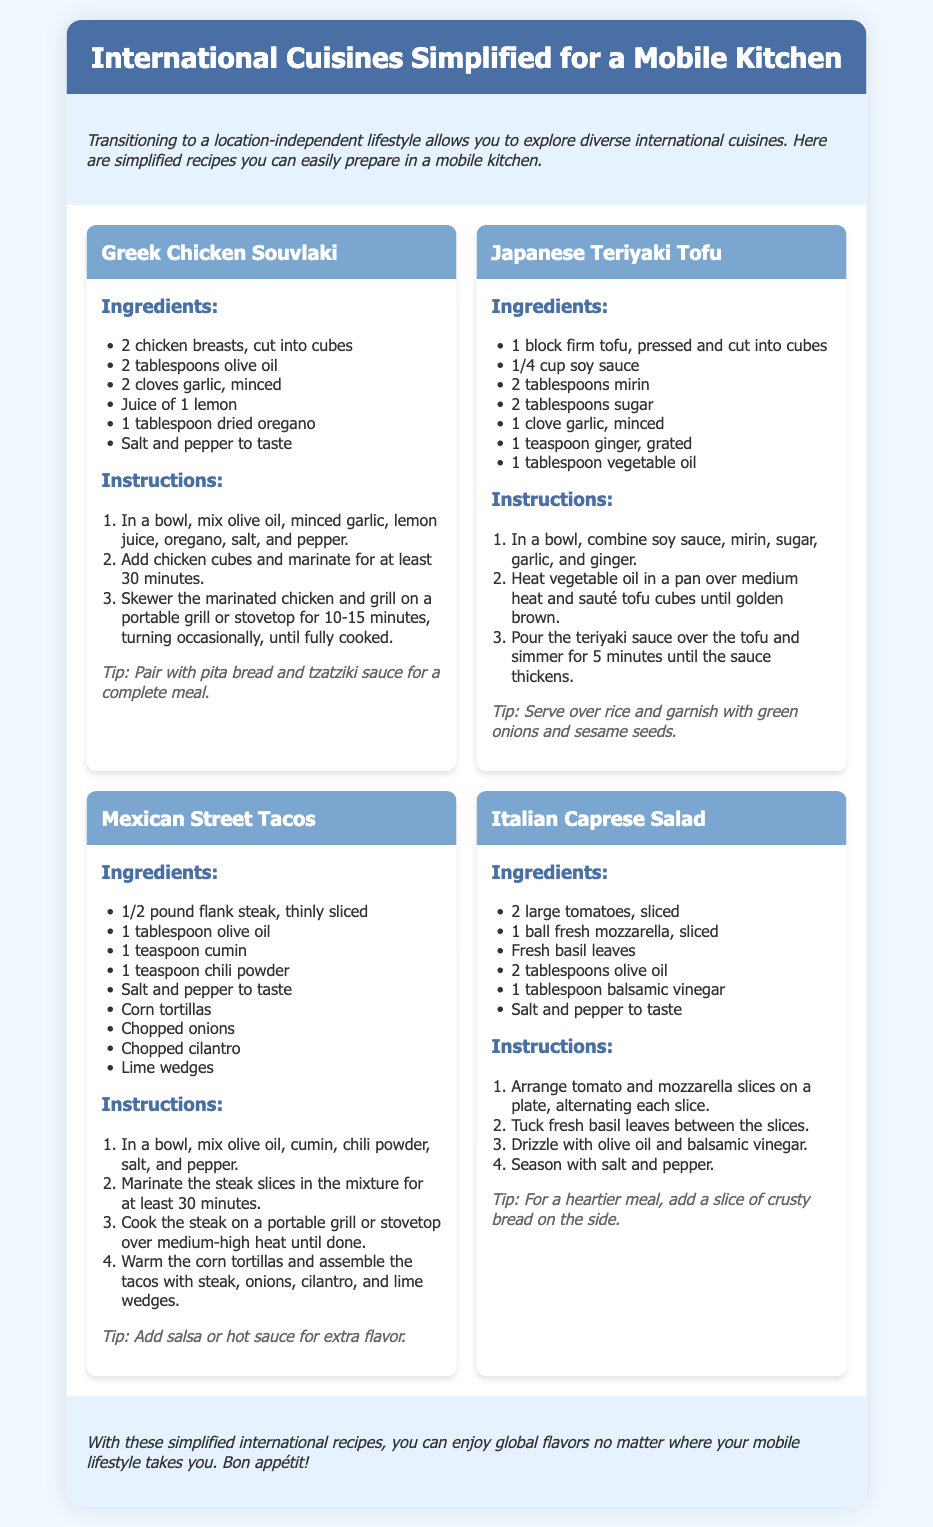what is the title of the document? The title of the document is prominently displayed at the top in the header section.
Answer: International Cuisines Simplified for a Mobile Kitchen how many recipes are included in the document? There are four distinct recipes presented in the recipe grid section.
Answer: 4 what is one ingredient in the Greek Chicken Souvlaki? The recipe card for Greek Chicken Souvlaki lists several ingredients, including olive oil, which is mentioned first.
Answer: olive oil what type of cuisine does the Japanese recipe focus on? The recipe for Japanese Teriyaki Tofu indicates it is part of Japanese cuisine, based on the title and ingredients.
Answer: Japanese what is the cooking method suggested for the Mexican Street Tacos? The instructions for the Mexican Street Tacos specify cooking the steak on a portable grill or stovetop.
Answer: grill or stovetop which ingredient is common in the Caprese Salad recipe? The Caprese Salad includes fresh mozzarella, a key ingredient in the dish.
Answer: fresh mozzarella how long should the chicken be marinated in the Greek Chicken Souvlaki recipe? The instructions indicate to marinate the chicken for at least 30 minutes.
Answer: 30 minutes what is a serving suggestion for the Japanese Teriyaki Tofu? The recipe suggests serving the teriyaki tofu over rice, which is mentioned in the tip.
Answer: over rice 